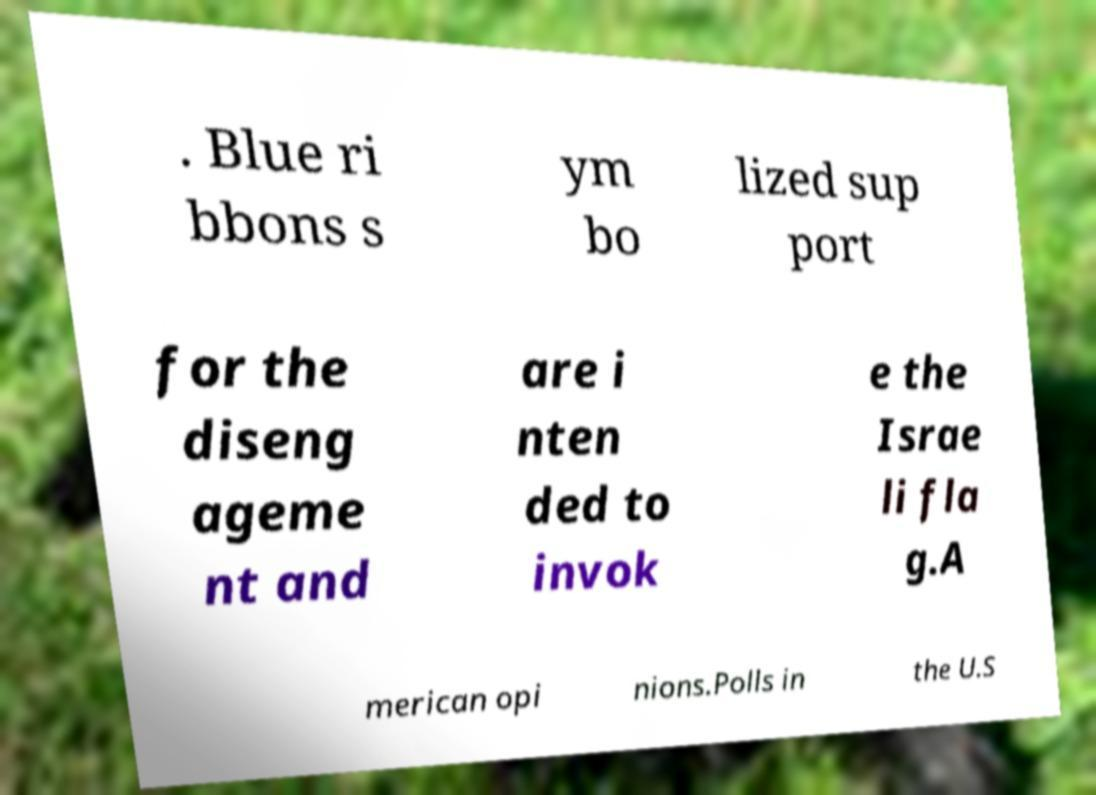What messages or text are displayed in this image? I need them in a readable, typed format. . Blue ri bbons s ym bo lized sup port for the diseng ageme nt and are i nten ded to invok e the Israe li fla g.A merican opi nions.Polls in the U.S 